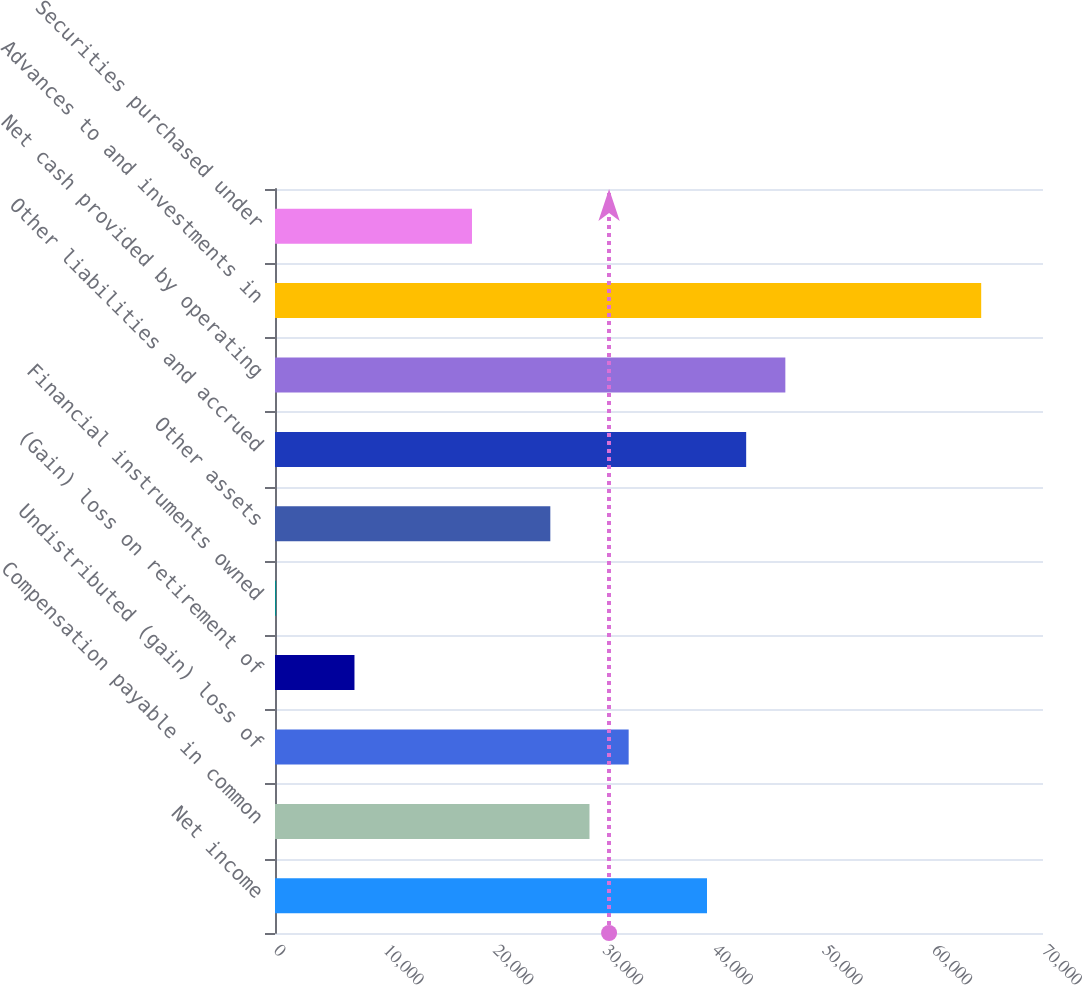Convert chart. <chart><loc_0><loc_0><loc_500><loc_500><bar_chart><fcel>Net income<fcel>Compensation payable in common<fcel>Undistributed (gain) loss of<fcel>(Gain) loss on retirement of<fcel>Financial instruments owned<fcel>Other assets<fcel>Other liabilities and accrued<fcel>Net cash provided by operating<fcel>Advances to and investments in<fcel>Securities purchased under<nl><fcel>39375.2<fcel>28664.6<fcel>32234.8<fcel>7243.4<fcel>103<fcel>25094.4<fcel>42945.4<fcel>46515.6<fcel>64366.6<fcel>17954<nl></chart> 